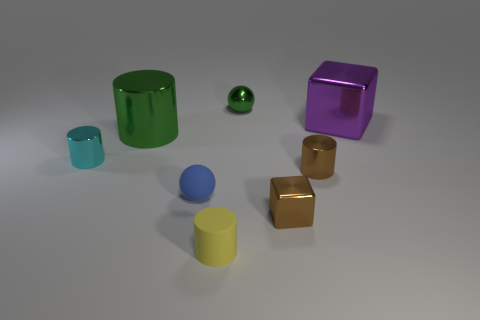Does the green ball have the same material as the big purple object?
Offer a terse response. Yes. What number of brown things are either small rubber cylinders or tiny cubes?
Offer a terse response. 1. Is the number of blue matte balls to the left of the small cyan cylinder greater than the number of green cylinders?
Your answer should be very brief. No. Are there any rubber objects of the same color as the small metallic block?
Your answer should be compact. No. What is the size of the brown metallic cylinder?
Keep it short and to the point. Small. Is the rubber cylinder the same color as the small shiny sphere?
Your answer should be compact. No. How many objects are either big green metallic spheres or brown objects in front of the blue matte sphere?
Provide a short and direct response. 1. How many tiny cyan objects are to the right of the brown thing behind the metallic cube that is to the left of the tiny brown cylinder?
Ensure brevity in your answer.  0. There is a tiny thing that is the same color as the tiny shiny cube; what is it made of?
Make the answer very short. Metal. How many big red blocks are there?
Provide a short and direct response. 0. 